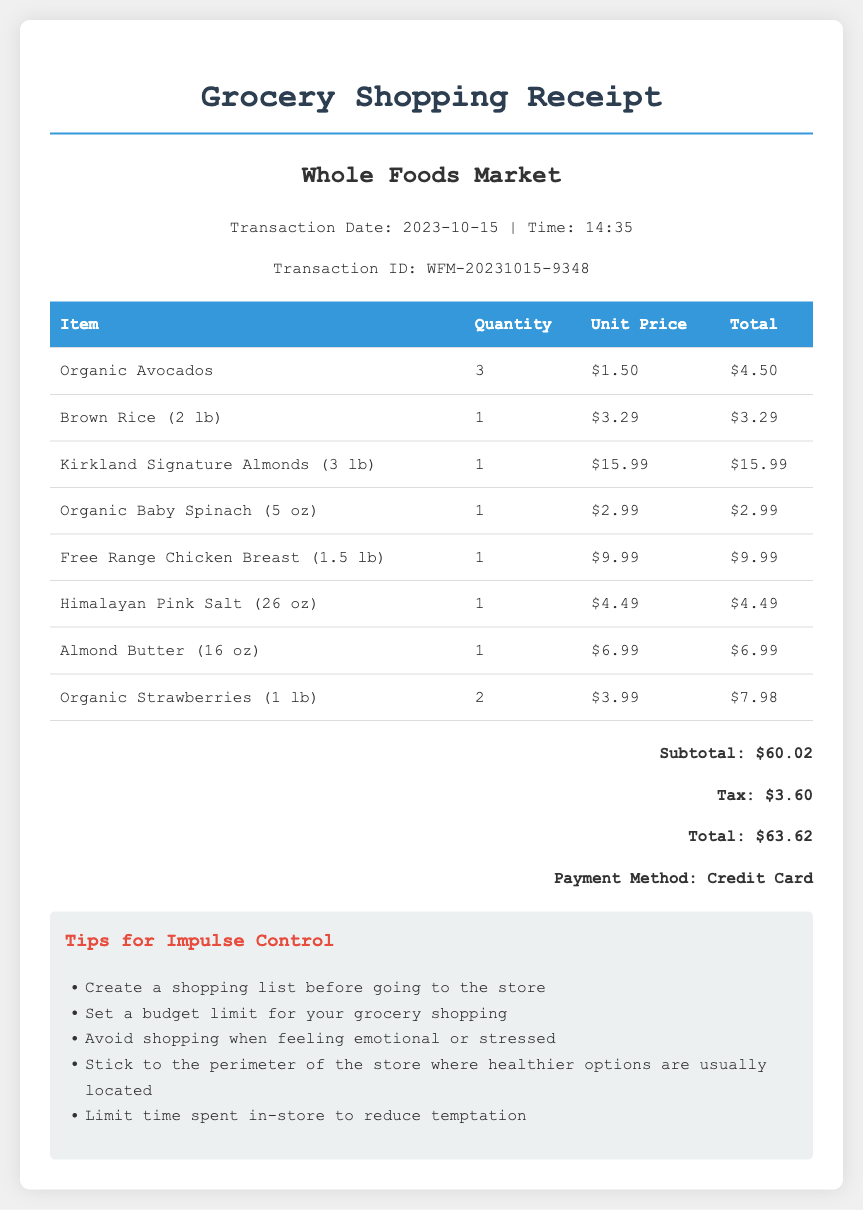What is the transaction date? The transaction date is explicitly stated in the store information section of the document.
Answer: 2023-10-15 How much are the Organic Avocados? The price for Organic Avocados can be found in the table listing grocery items and their prices.
Answer: $4.50 What is the payment method used? The payment method is detailed at the end of the receipt in the total section.
Answer: Credit Card What is the total amount spent? The total amount is summarized at the bottom of the receipt under the total section.
Answer: $63.62 How many items were purchased in total? To find the total items, we must count the number of item rows in the receipt table.
Answer: 8 What is the subtotal before tax? The subtotal is provided in the total section of the receipt, before tax was added.
Answer: $60.02 What type of store is this receipt from? The store type can be inferred from the store information section at the top of the receipt.
Answer: Whole Foods Market What tips are given for impulse control? Tips are outlined in a specific section intended to help with impulse control related to grocery shopping.
Answer: Create a shopping list before going to the store 